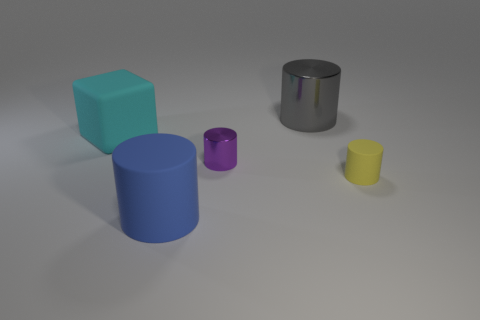What shape is the thing that is the same material as the purple cylinder?
Provide a short and direct response. Cylinder. How many yellow objects are either large matte objects or big rubber cubes?
Provide a short and direct response. 0. Is there a large thing that is to the right of the big rubber object that is behind the big thing that is in front of the cyan matte object?
Keep it short and to the point. Yes. Is the number of gray objects less than the number of metal cylinders?
Your answer should be compact. Yes. There is a object behind the big cyan thing; is its shape the same as the purple shiny object?
Keep it short and to the point. Yes. Are any matte cylinders visible?
Offer a terse response. Yes. What is the color of the matte object that is behind the small thing left of the large cylinder that is right of the purple metal object?
Provide a succinct answer. Cyan. Is the number of big metallic things in front of the large gray shiny object the same as the number of small yellow cylinders to the left of the purple metallic cylinder?
Your response must be concise. Yes. There is another matte thing that is the same size as the cyan object; what shape is it?
Make the answer very short. Cylinder. What is the shape of the cyan thing behind the small yellow rubber thing?
Your answer should be very brief. Cube. 